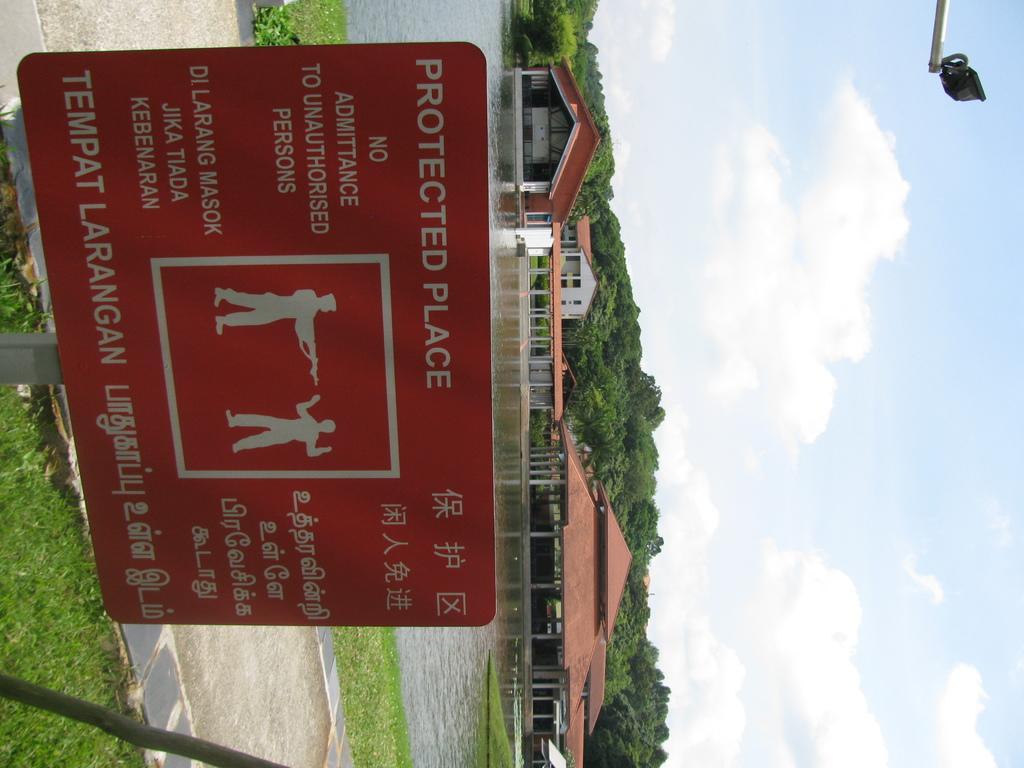Please provide a concise description of this image. In this image we can see a board with the text. We can also see the path, grass, houses and also the roof for shelter. We can see the water and also the trees. We can also see the sky with the clouds. There is also an object. 